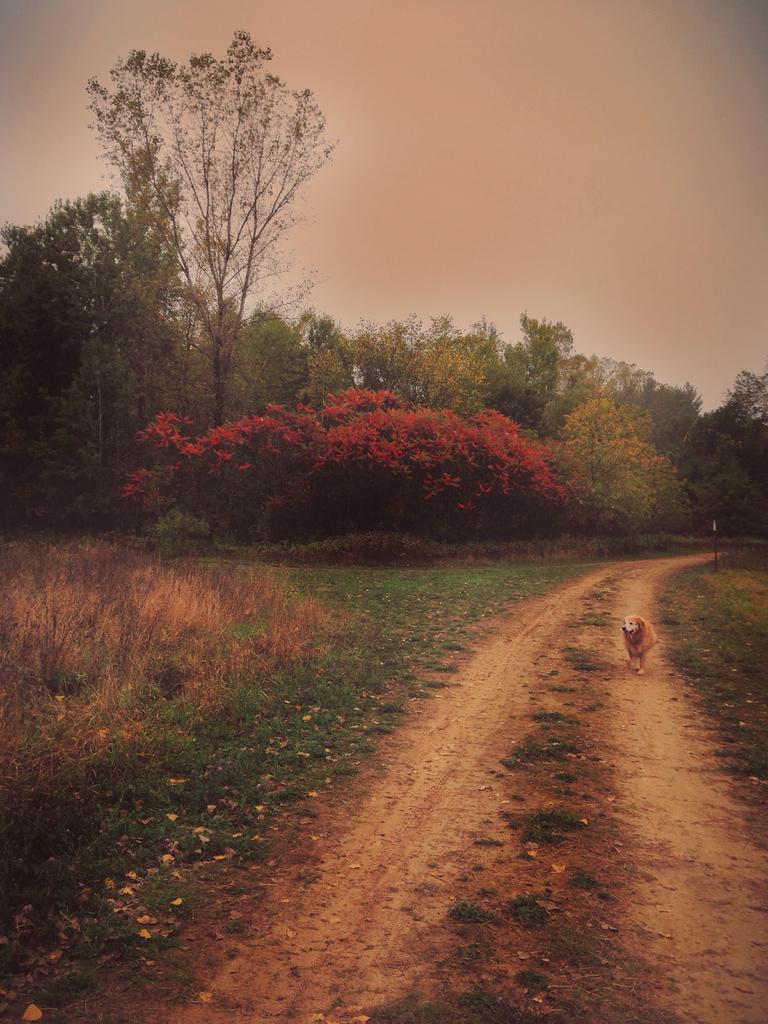In one or two sentences, can you explain what this image depicts? In this image on the right, there is a dog. At the bottom there are plants and grass. In the background there are trees and sky. 